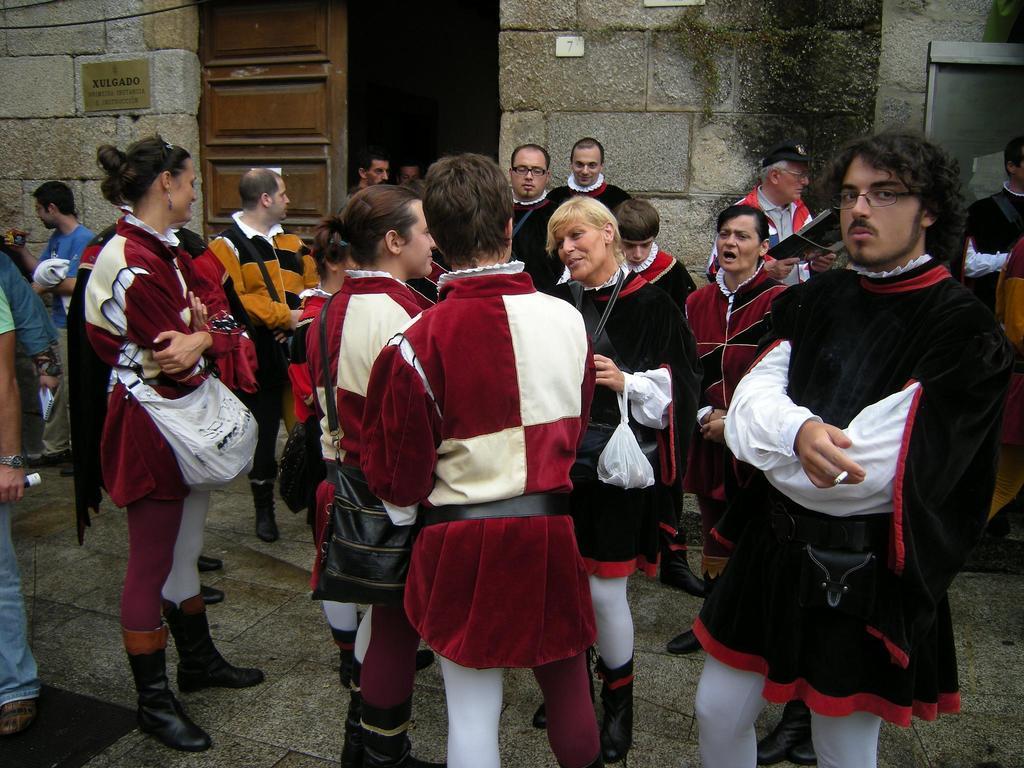In one or two sentences, can you explain what this image depicts? In the image we can see there are many people around, standing, wearing clothes and boots, and some people are wearing spectacles. This is a footpath, handbag, wrist watch, cigarette, stone wall and a door. This is a plastic cover. 